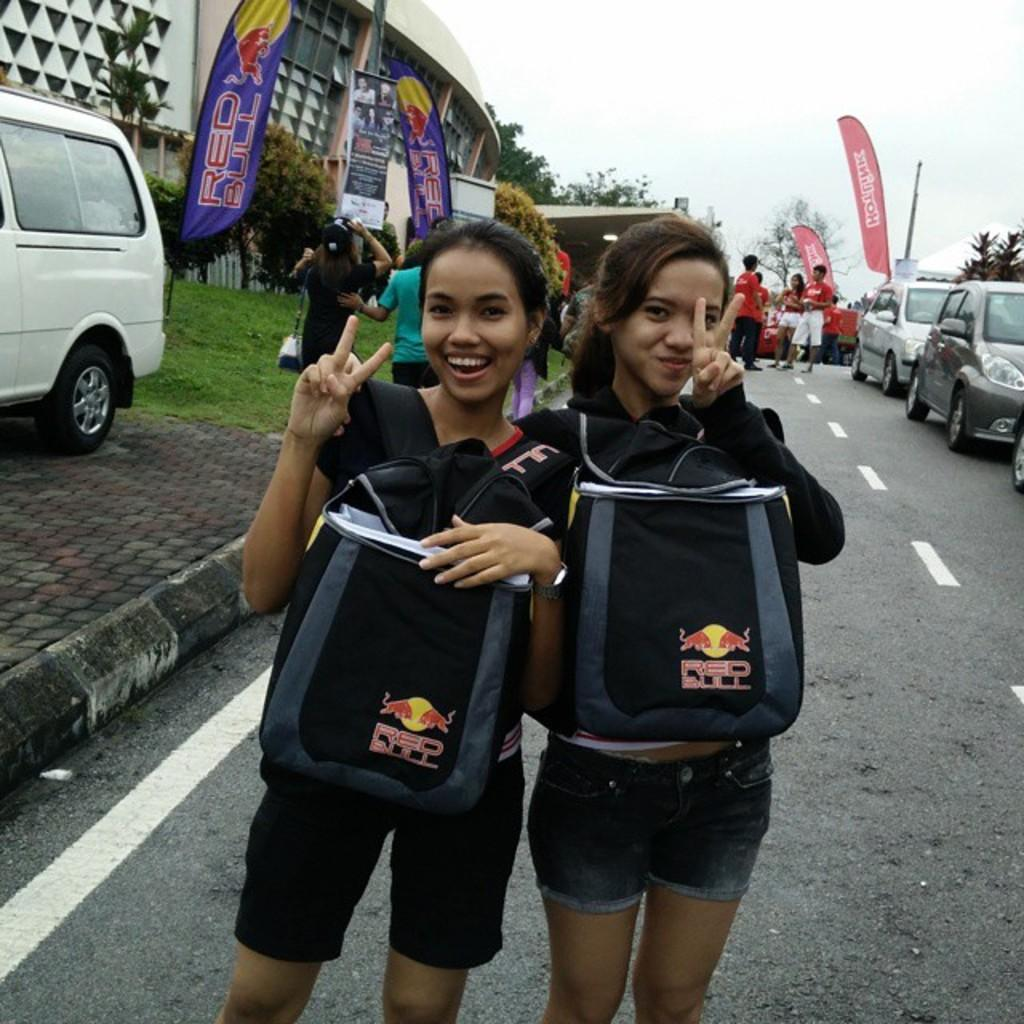How many women are in the image? There are two women in the image. What are the women doing in the image? The women are standing and smiling in the image. What are the women holding in the image? The women are carrying bags in the image. What type of terrain is visible in the image? There is grass visible in the image. What type of man-made structures can be seen in the image? There are vehicles, a road, and a building visible in the image. What is visible in the background of the image? In the background of the image, there are banners, a pole, trees, and the sky. What type of hospital can be seen in the background of the image? There is no hospital present in the image; the background features banners, a pole, trees, and the sky. 